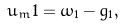Convert formula to latex. <formula><loc_0><loc_0><loc_500><loc_500>u _ { m } 1 = \omega _ { 1 } - g _ { 1 } ,</formula> 